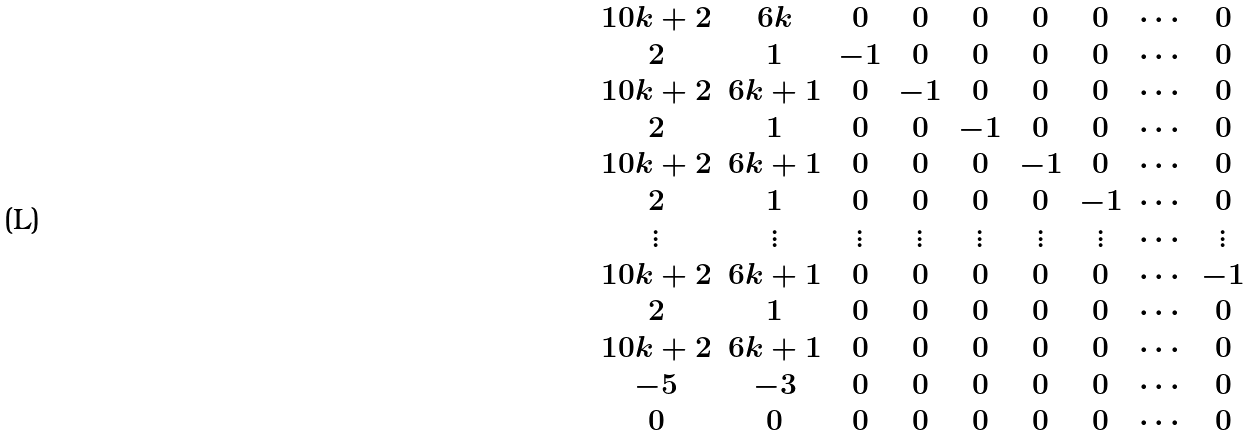<formula> <loc_0><loc_0><loc_500><loc_500>\begin{matrix} 1 0 k + 2 & 6 k & 0 & 0 & 0 & 0 & 0 & \cdots & 0 \\ 2 & 1 & - 1 & 0 & 0 & 0 & 0 & \cdots & 0 \\ 1 0 k + 2 & 6 k + 1 & 0 & - 1 & 0 & 0 & 0 & \cdots & 0 \\ 2 & 1 & 0 & 0 & - 1 & 0 & 0 & \cdots & 0 \\ 1 0 k + 2 & 6 k + 1 & 0 & 0 & 0 & - 1 & 0 & \cdots & 0 \\ 2 & 1 & 0 & 0 & 0 & 0 & - 1 & \cdots & 0 \\ \vdots & \vdots & \vdots & \vdots & \vdots & \vdots & \vdots & \cdots & \vdots \\ 1 0 k + 2 & 6 k + 1 & 0 & 0 & 0 & 0 & 0 & \cdots & - 1 \\ 2 & 1 & 0 & 0 & 0 & 0 & 0 & \cdots & 0 \\ 1 0 k + 2 & 6 k + 1 & 0 & 0 & 0 & 0 & 0 & \cdots & 0 \\ - 5 & - 3 & 0 & 0 & 0 & 0 & 0 & \cdots & 0 \\ 0 & 0 & 0 & 0 & 0 & 0 & 0 & \cdots & 0 \end{matrix}</formula> 